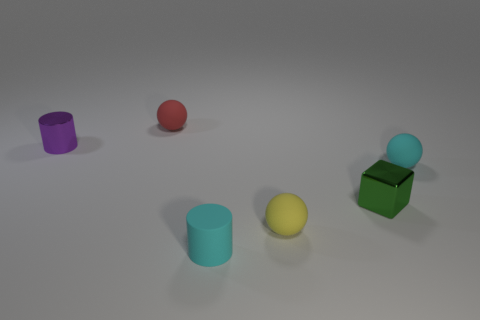Add 2 big yellow shiny balls. How many objects exist? 8 Subtract all cubes. How many objects are left? 5 Add 5 rubber things. How many rubber things are left? 9 Add 1 large red metallic objects. How many large red metallic objects exist? 1 Subtract 0 blue cubes. How many objects are left? 6 Subtract all small red balls. Subtract all tiny cyan cylinders. How many objects are left? 4 